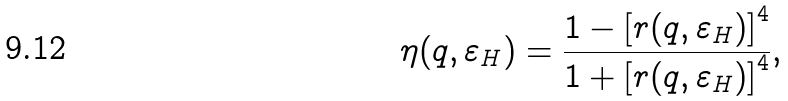Convert formula to latex. <formula><loc_0><loc_0><loc_500><loc_500>\eta ( q , \varepsilon _ { H } ) = \frac { 1 - \left [ r ( q , \varepsilon _ { H } ) \right ] ^ { 4 } } { 1 + \left [ r ( q , \varepsilon _ { H } ) \right ] ^ { 4 } } ,</formula> 